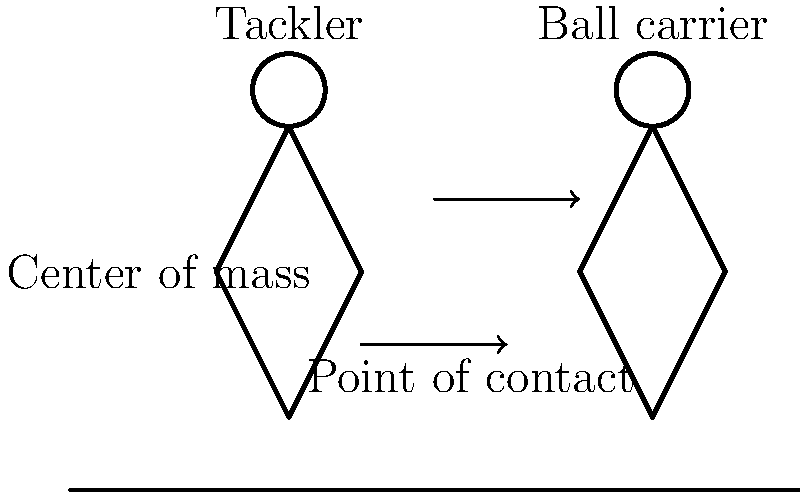In a proper rugby tackle, why is it important for the tackler to aim for the ball carrier's center of mass rather than their legs or upper body? Refer to the biomechanical principles illustrated in the diagram. To understand the importance of targeting the center of mass in a rugby tackle, let's break down the biomechanical principles involved:

1. Center of mass: The center of mass is the point where the body's mass is concentrated. In the diagram, it's roughly at the hip level for both players.

2. Stability: Targeting the center of mass disrupts the ball carrier's stability most effectively. When force is applied at this point, it's harder for the ball carrier to maintain balance.

3. Momentum transfer: The tackler's momentum is most efficiently transferred to the ball carrier when contact is made at the center of mass. This results in a more effective tackle.

4. Reduced risk of injury: Aiming for the center of mass reduces the risk of high tackles (which can cause head/neck injuries) or low tackles (which can cause knee/ankle injuries).

5. Control: Wrapping arms around the center of mass provides better control over the ball carrier's movement, making it easier to bring them to the ground.

6. Force distribution: Contact at the center of mass distributes the impact force more evenly across the body, reducing the risk of concentrated trauma to specific body parts.

7. Lever principle: Tackling at the center of mass minimizes the ball carrier's ability to use their body as a lever to break the tackle.

By aiming for the center of mass, the tackler maximizes the effectiveness of the tackle while minimizing the risk of injury to both players.
Answer: Targeting the center of mass maximizes tackle effectiveness and minimizes injury risk. 